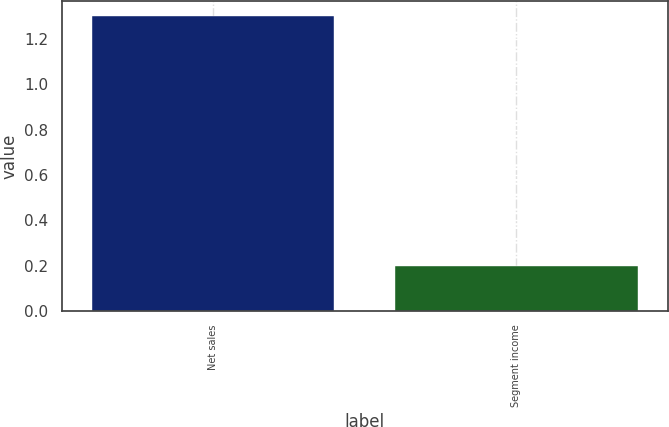Convert chart. <chart><loc_0><loc_0><loc_500><loc_500><bar_chart><fcel>Net sales<fcel>Segment income<nl><fcel>1.3<fcel>0.2<nl></chart> 